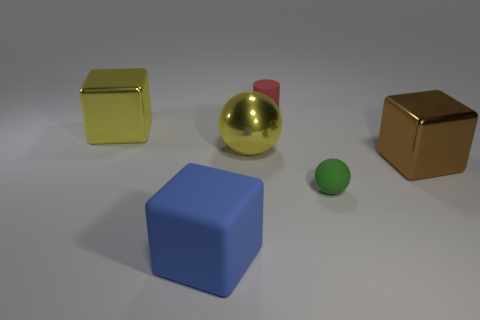There is a sphere that is the same size as the brown block; what is it made of?
Your response must be concise. Metal. Are there any large brown objects of the same shape as the tiny red object?
Keep it short and to the point. No. There is a object that is the same color as the large ball; what is its material?
Provide a succinct answer. Metal. The metallic thing that is to the right of the small green matte ball has what shape?
Make the answer very short. Cube. What number of small green balls are there?
Your answer should be compact. 1. What color is the large thing that is the same material as the green ball?
Make the answer very short. Blue. What number of large objects are either cyan spheres or yellow shiny objects?
Offer a very short reply. 2. There is a brown thing; what number of tiny objects are to the right of it?
Make the answer very short. 0. There is a shiny thing that is the same shape as the tiny green rubber thing; what color is it?
Make the answer very short. Yellow. What number of rubber things are either yellow blocks or large spheres?
Offer a terse response. 0. 